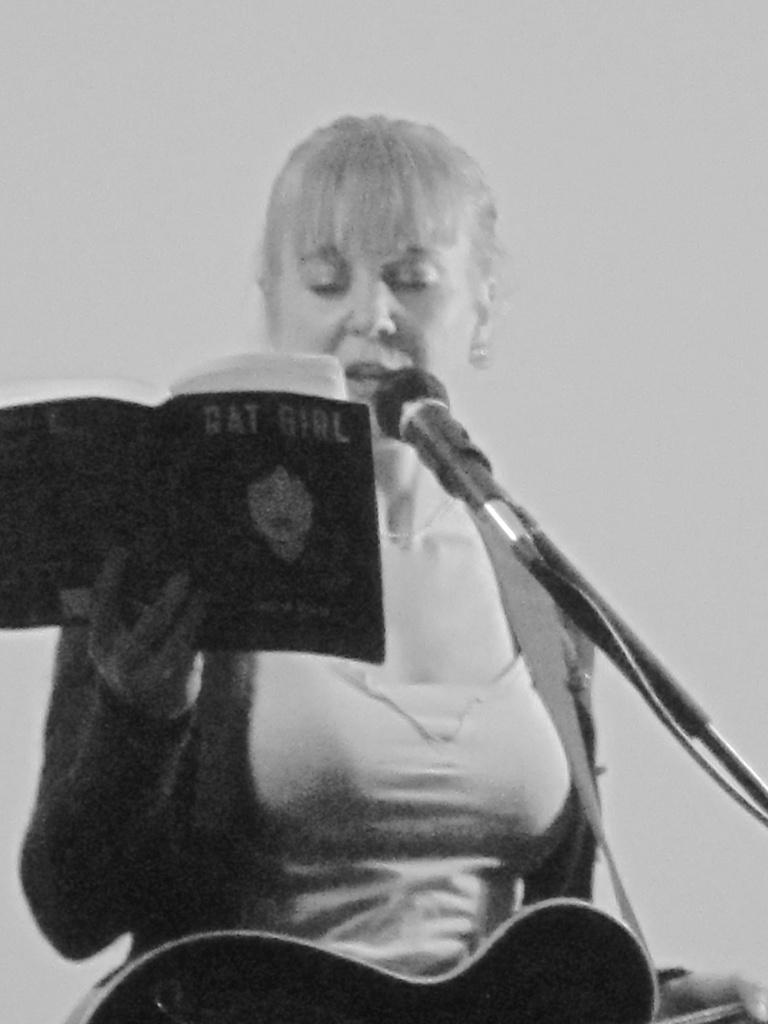Who is the main subject in the image? There is a woman in the image. What is the woman doing in the image? The woman is sitting and singing a song. What object is the woman holding in the image? The woman is holding a microphone. What is the woman looking at in the image? The woman is looking at a book. How does the woman increase the flow of water in the image? There is no reference to water or any action related to increasing flow in the image. The woman is singing and looking at a book while holding a microphone. 